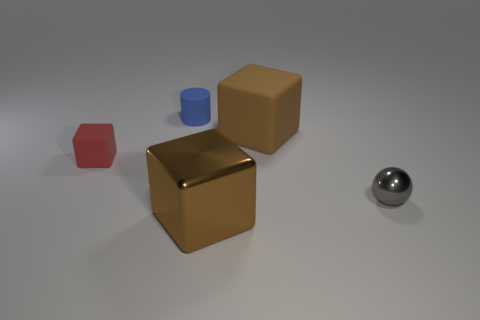How many metallic cubes are in front of the brown block to the left of the big brown matte cube?
Provide a short and direct response. 0. Is there any other thing that has the same shape as the gray object?
Provide a short and direct response. No. Do the small thing that is behind the red rubber thing and the big thing that is behind the red thing have the same color?
Give a very brief answer. No. Is the number of metallic things less than the number of shiny cylinders?
Your answer should be very brief. No. What shape is the tiny thing that is left of the small thing behind the big rubber thing?
Ensure brevity in your answer.  Cube. Is there any other thing that has the same size as the gray metal ball?
Provide a succinct answer. Yes. There is a metal object to the left of the brown object behind the large block in front of the tiny metal sphere; what shape is it?
Provide a short and direct response. Cube. How many things are either objects in front of the red matte cube or metallic objects right of the large rubber block?
Provide a succinct answer. 2. Does the red rubber cube have the same size as the brown thing that is behind the gray shiny object?
Keep it short and to the point. No. Do the cube on the left side of the tiny blue cylinder and the large brown thing behind the tiny ball have the same material?
Your response must be concise. Yes. 